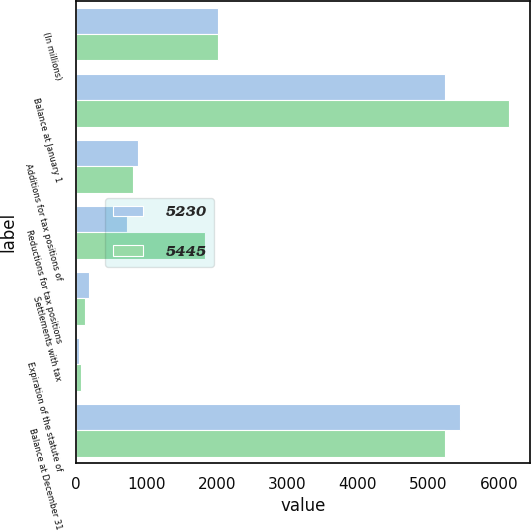Convert chart to OTSL. <chart><loc_0><loc_0><loc_500><loc_500><stacked_bar_chart><ecel><fcel>(In millions)<fcel>Balance at January 1<fcel>Additions for tax positions of<fcel>Reductions for tax positions<fcel>Settlements with tax<fcel>Expiration of the statute of<fcel>Balance at December 31<nl><fcel>5230<fcel>2012<fcel>5230<fcel>882<fcel>723<fcel>191<fcel>46<fcel>5445<nl><fcel>5445<fcel>2011<fcel>6139<fcel>817<fcel>1828<fcel>127<fcel>76<fcel>5230<nl></chart> 